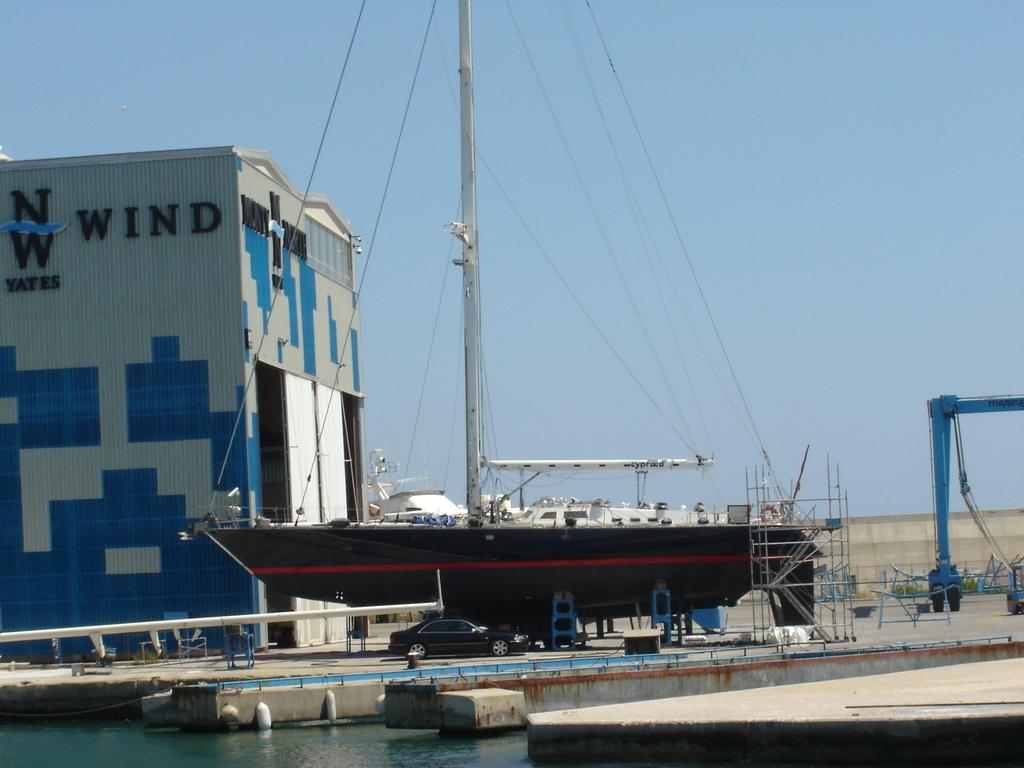What types of transportation are present in the image? There are vehicles and a ship in the image. Where are the vehicles and ship located in relation to the water? The vehicles and ship are placed beside the water. How many horses are present in the image? There are no horses present in the image. 